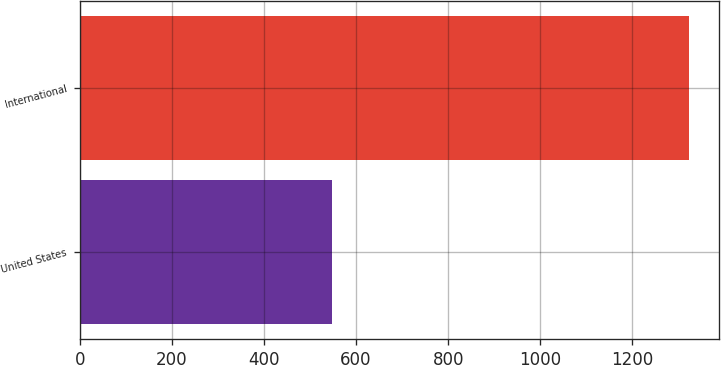Convert chart. <chart><loc_0><loc_0><loc_500><loc_500><bar_chart><fcel>United States<fcel>International<nl><fcel>548.4<fcel>1321.9<nl></chart> 